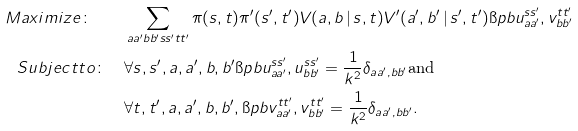<formula> <loc_0><loc_0><loc_500><loc_500>M a x i m i z e \colon \quad & \sum _ { a a ^ { \prime } b b ^ { \prime } s s ^ { \prime } t t ^ { \prime } } \pi ( s , t ) \pi ^ { \prime } ( s ^ { \prime } , t ^ { \prime } ) V ( a , b \, | \, s , t ) V ^ { \prime } ( a ^ { \prime } , b ^ { \prime } \, | \, s ^ { \prime } , t ^ { \prime } ) \i p b { u _ { a a ^ { \prime } } ^ { s s ^ { \prime } } , v _ { b b ^ { \prime } } ^ { t t ^ { \prime } } } \\ S u b j e c t t o \colon \quad & \forall s , s ^ { \prime } , a , a ^ { \prime } , b , b ^ { \prime } \i p b { u _ { a a ^ { \prime } } ^ { s s ^ { \prime } } , u _ { b b ^ { \prime } } ^ { s s ^ { \prime } } } = \frac { 1 } { k ^ { 2 } } \delta _ { a a ^ { \prime } , b b ^ { \prime } } \text {and} \\ & \forall t , t ^ { \prime } , a , a ^ { \prime } , b , b ^ { \prime } , \i p b { v _ { a a ^ { \prime } } ^ { t t ^ { \prime } } , v _ { b b ^ { \prime } } ^ { t t ^ { \prime } } } = \frac { 1 } { k ^ { 2 } } \delta _ { a a ^ { \prime } , b b ^ { \prime } } .</formula> 